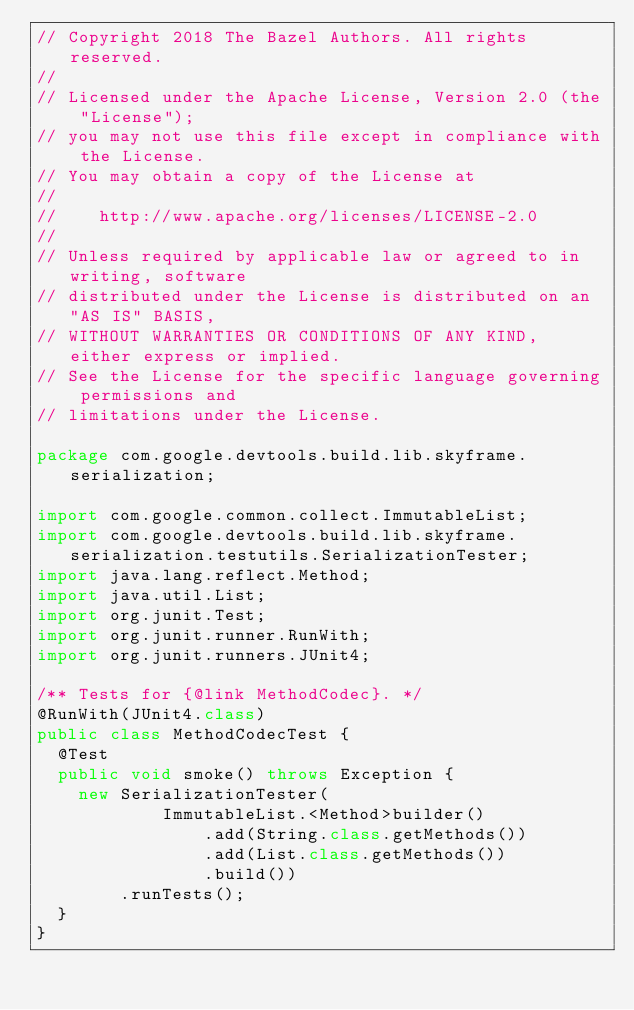<code> <loc_0><loc_0><loc_500><loc_500><_Java_>// Copyright 2018 The Bazel Authors. All rights reserved.
//
// Licensed under the Apache License, Version 2.0 (the "License");
// you may not use this file except in compliance with the License.
// You may obtain a copy of the License at
//
//    http://www.apache.org/licenses/LICENSE-2.0
//
// Unless required by applicable law or agreed to in writing, software
// distributed under the License is distributed on an "AS IS" BASIS,
// WITHOUT WARRANTIES OR CONDITIONS OF ANY KIND, either express or implied.
// See the License for the specific language governing permissions and
// limitations under the License.

package com.google.devtools.build.lib.skyframe.serialization;

import com.google.common.collect.ImmutableList;
import com.google.devtools.build.lib.skyframe.serialization.testutils.SerializationTester;
import java.lang.reflect.Method;
import java.util.List;
import org.junit.Test;
import org.junit.runner.RunWith;
import org.junit.runners.JUnit4;

/** Tests for {@link MethodCodec}. */
@RunWith(JUnit4.class)
public class MethodCodecTest {
  @Test
  public void smoke() throws Exception {
    new SerializationTester(
            ImmutableList.<Method>builder()
                .add(String.class.getMethods())
                .add(List.class.getMethods())
                .build())
        .runTests();
  }
}
</code> 